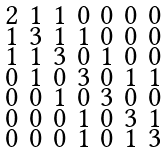Convert formula to latex. <formula><loc_0><loc_0><loc_500><loc_500>\begin{smallmatrix} 2 & 1 & 1 & 0 & 0 & 0 & 0 \\ 1 & 3 & 1 & 1 & 0 & 0 & 0 \\ 1 & 1 & 3 & 0 & 1 & 0 & 0 \\ 0 & 1 & 0 & 3 & 0 & 1 & 1 \\ 0 & 0 & 1 & 0 & 3 & 0 & 0 \\ 0 & 0 & 0 & 1 & 0 & 3 & 1 \\ 0 & 0 & 0 & 1 & 0 & 1 & 3 \end{smallmatrix}</formula> 